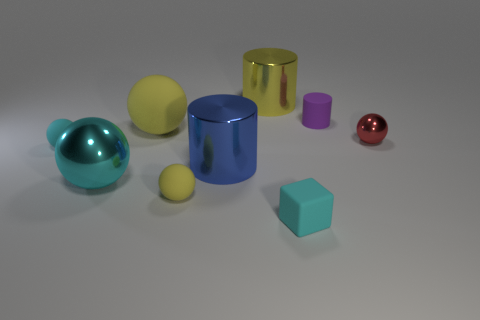The other cyan object that is the same shape as the big cyan thing is what size?
Keep it short and to the point. Small. What material is the big thing that is the same color as the large matte ball?
Provide a succinct answer. Metal. Is there another thing that has the same shape as the large blue shiny thing?
Your answer should be compact. Yes. How big is the metal sphere that is left of the tiny red ball?
Offer a terse response. Large. There is a yellow sphere that is on the left side of the ball that is in front of the large cyan sphere; what number of small red spheres are on the left side of it?
Make the answer very short. 0. Do the rubber cube and the large metal ball have the same color?
Keep it short and to the point. Yes. How many cyan rubber things are both behind the tiny cyan block and in front of the large metallic sphere?
Your answer should be very brief. 0. There is a small thing that is right of the small purple rubber cylinder; what shape is it?
Offer a terse response. Sphere. Are there fewer matte balls that are to the right of the purple matte object than red things that are on the right side of the red metal ball?
Keep it short and to the point. No. Is the large cylinder that is in front of the small purple matte cylinder made of the same material as the yellow ball that is in front of the large yellow sphere?
Keep it short and to the point. No. 